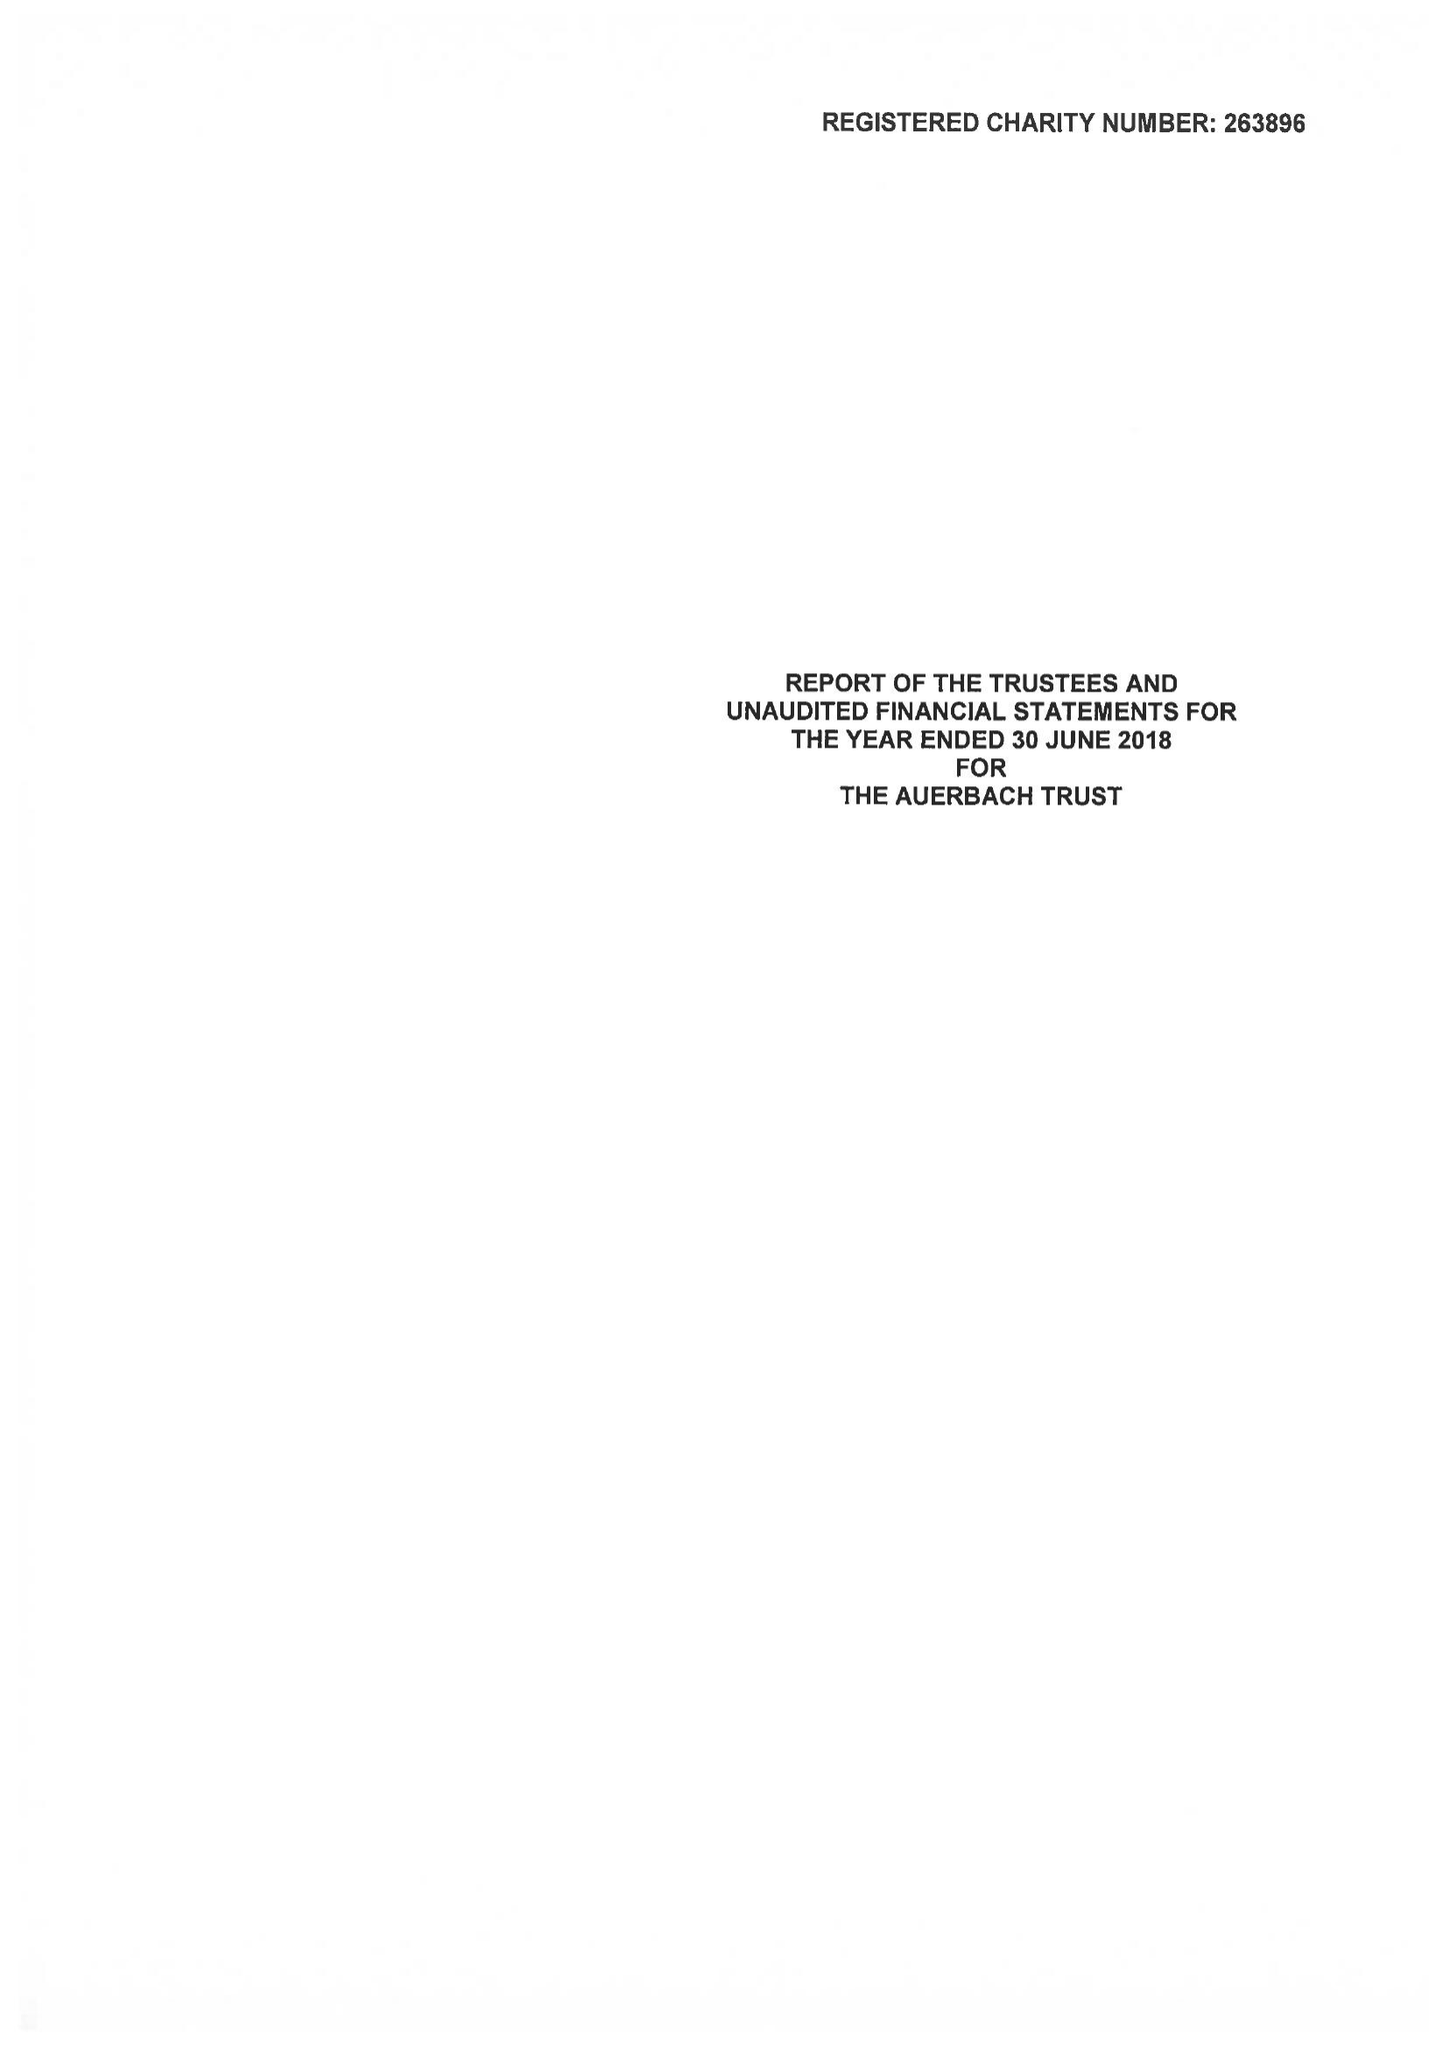What is the value for the income_annually_in_british_pounds?
Answer the question using a single word or phrase. 46159.00 